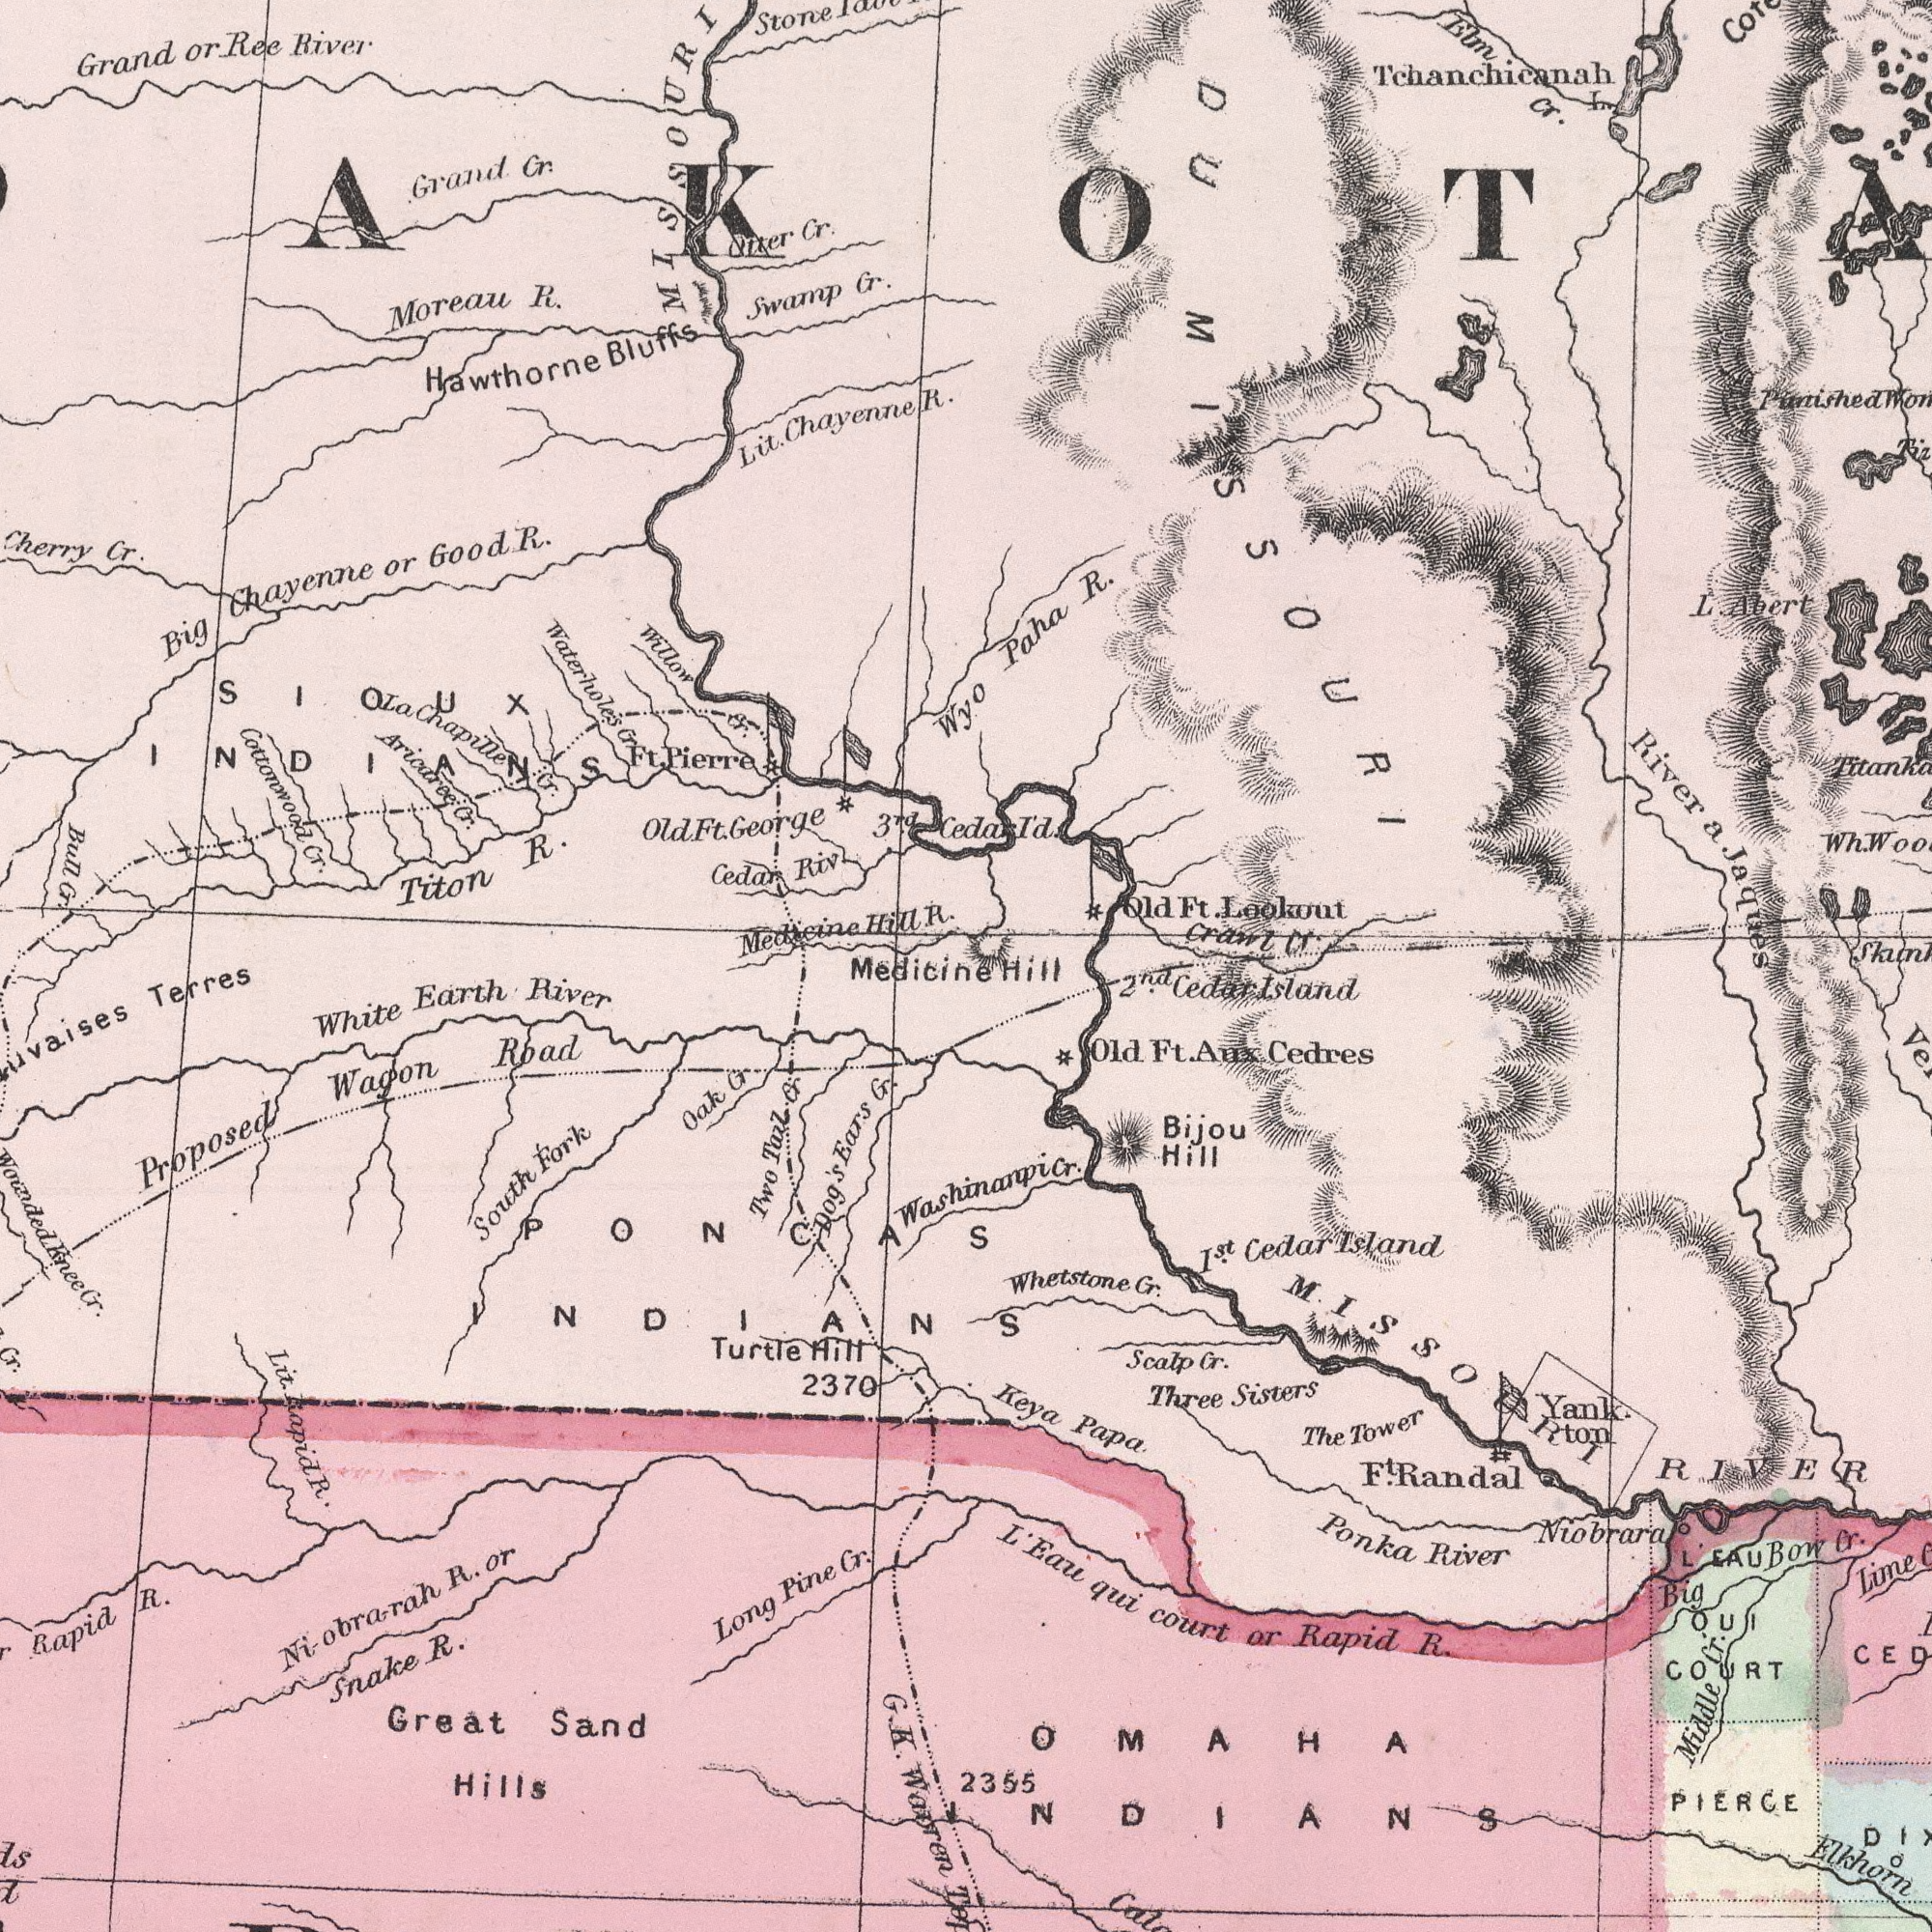What text is visible in the lower-right corner? Skum## Elkhorn L' Eau qui court or Rapid R. MISSOURI RIVER Niobrara Whetstone Cr. Keya Papa Ponka River Big Bow Cr. Old Ft. Aux Cedres I.st Cedar Island Scalp Cr. 2.nd Cedar Island The Tower F.t Randal Bijou Hill Lime PIERCE Yank ton Middle Cr. Three Sisters OMAHA INDIANS L' EAU OUI COURT 2355 Washinanpi Cr. Hill What text appears in the top-right area of the image? Paha R. Cedar I'd. Crawl Cr. River a. Jaques L. Abert Elm Cr. Tchanchicanah Old Ft. Lookout Wh. DU MISSOURI Punished What text can you see in the bottom-left section? G. K. Warren Dog's Ears Cr. Rapid R. Proposed Wagon Road White Earth River Great Sand Hills Long Pine Cr. Snake R. 2370 South Fork Lit. Rapid R. Terres Two Tail Cr Oak Cr Ni-obrarah R. or Turtle Hill Cr. Woundedknee Cr. PONCAS INDIANS Medicine What text appears in the top-left area of the image? Cottonwood Cr. Big Chayenne or Good R. Stone Oiter Cr. Bull Cr. Lit. Chayenne R. Grand or Ree River Waterholes Cr Medicine Hill R. Titon R. Hawthorne Bluffs Aricaree Cr. Moreau R. Cherry Cr. Grand Cr. Swamp Cr. Cedar Riv. Ft. Pierre Wyo La Chapille Cr. Willow Cr. 3.rd Old Ft. George SIOUX INDIANS MISSOURI 